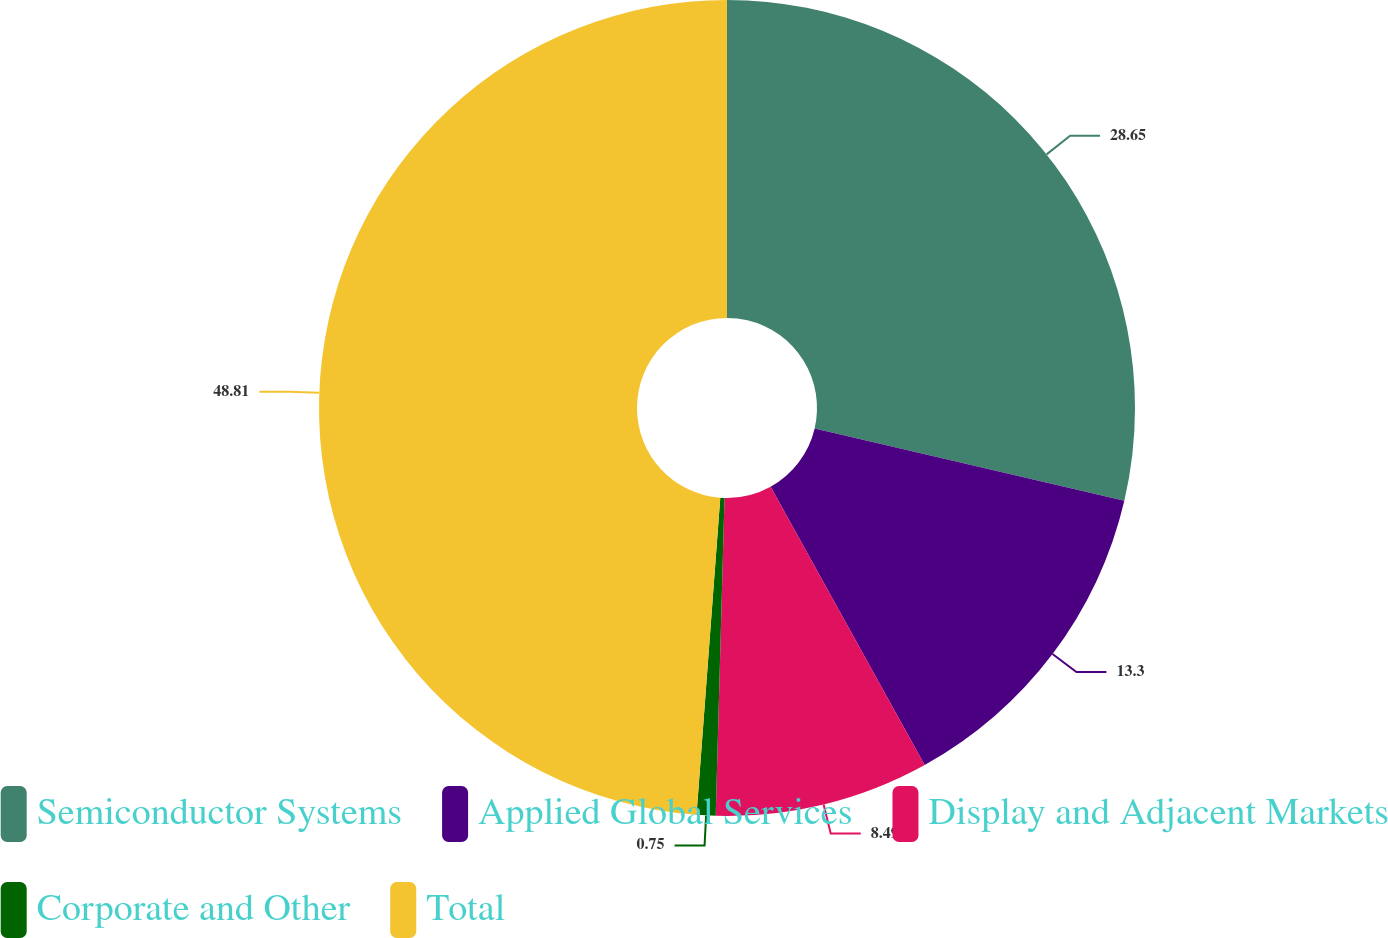<chart> <loc_0><loc_0><loc_500><loc_500><pie_chart><fcel>Semiconductor Systems<fcel>Applied Global Services<fcel>Display and Adjacent Markets<fcel>Corporate and Other<fcel>Total<nl><fcel>28.65%<fcel>13.3%<fcel>8.49%<fcel>0.75%<fcel>48.81%<nl></chart> 